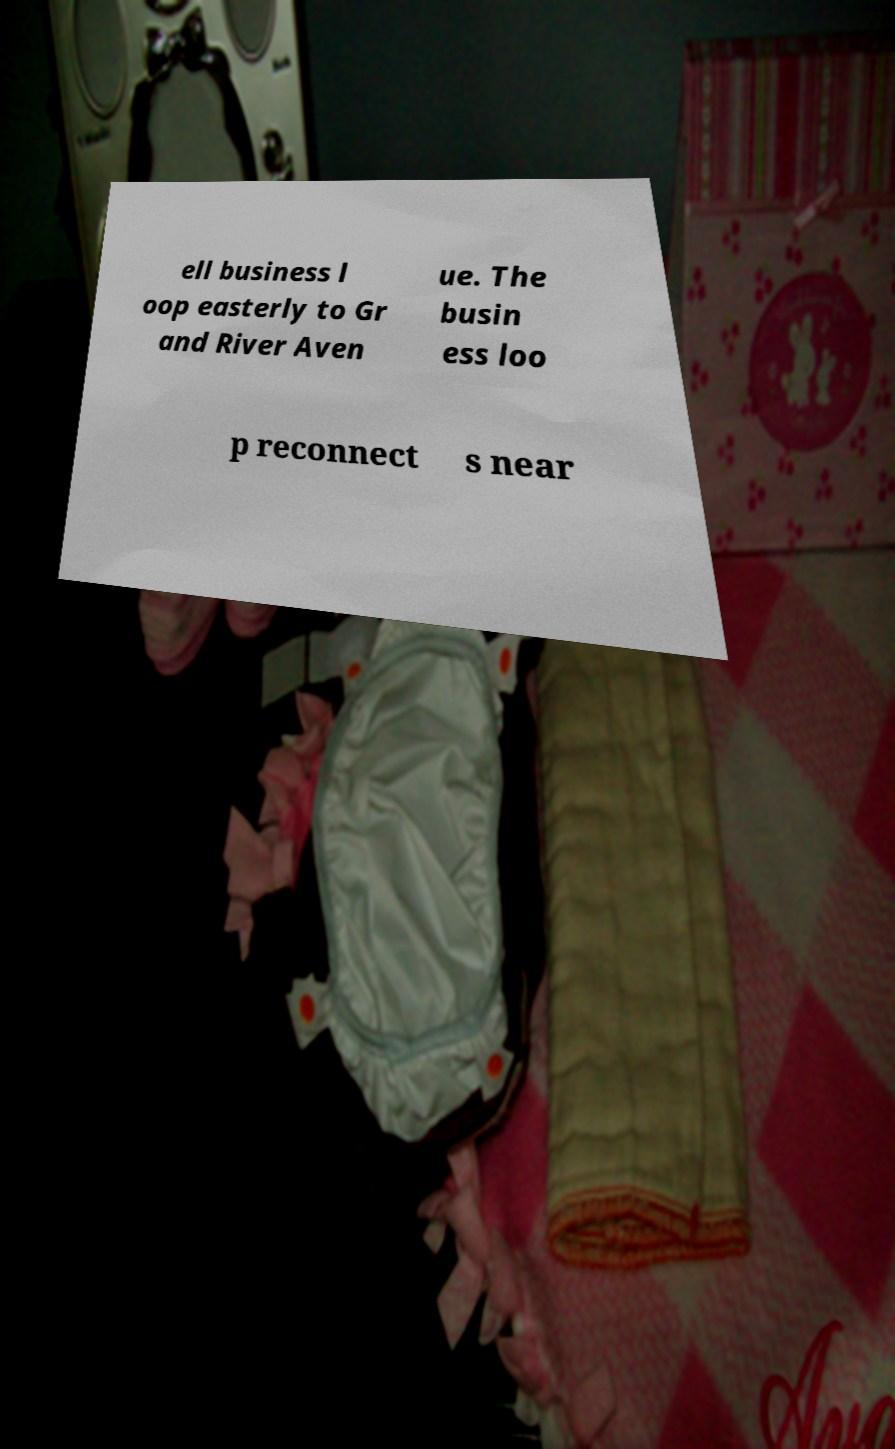Could you extract and type out the text from this image? ell business l oop easterly to Gr and River Aven ue. The busin ess loo p reconnect s near 